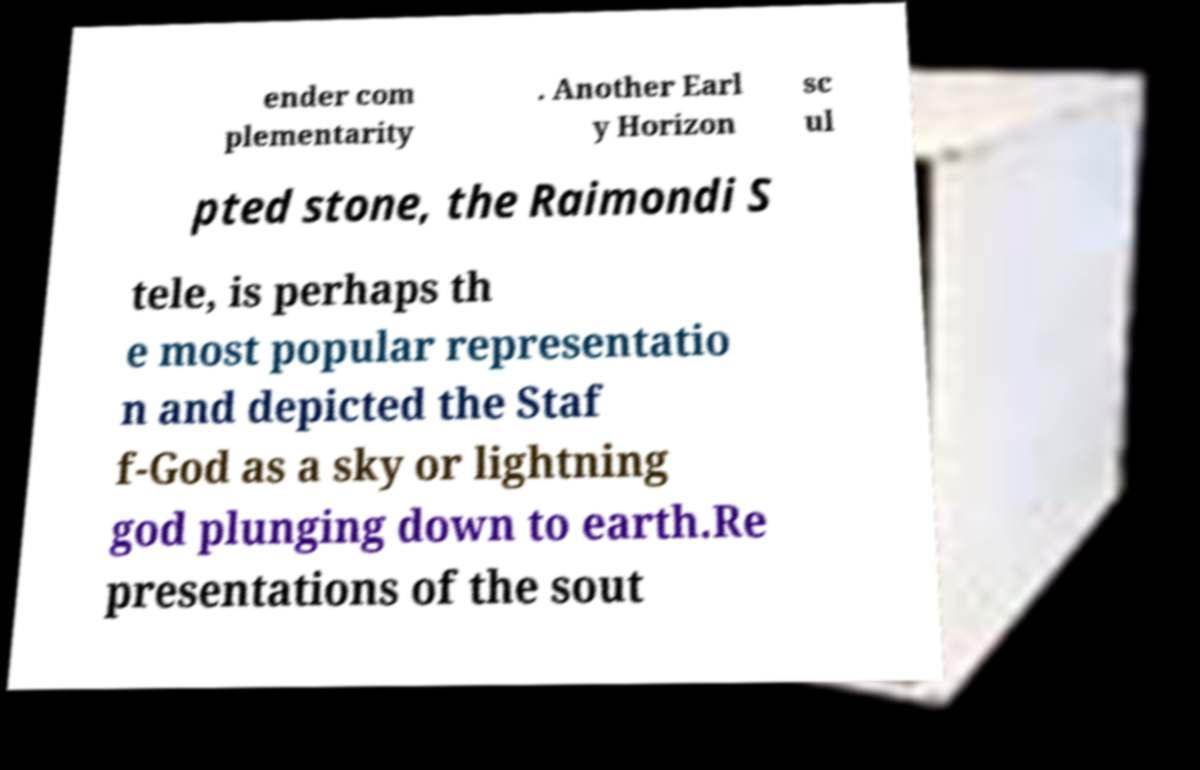What messages or text are displayed in this image? I need them in a readable, typed format. ender com plementarity . Another Earl y Horizon sc ul pted stone, the Raimondi S tele, is perhaps th e most popular representatio n and depicted the Staf f-God as a sky or lightning god plunging down to earth.Re presentations of the sout 